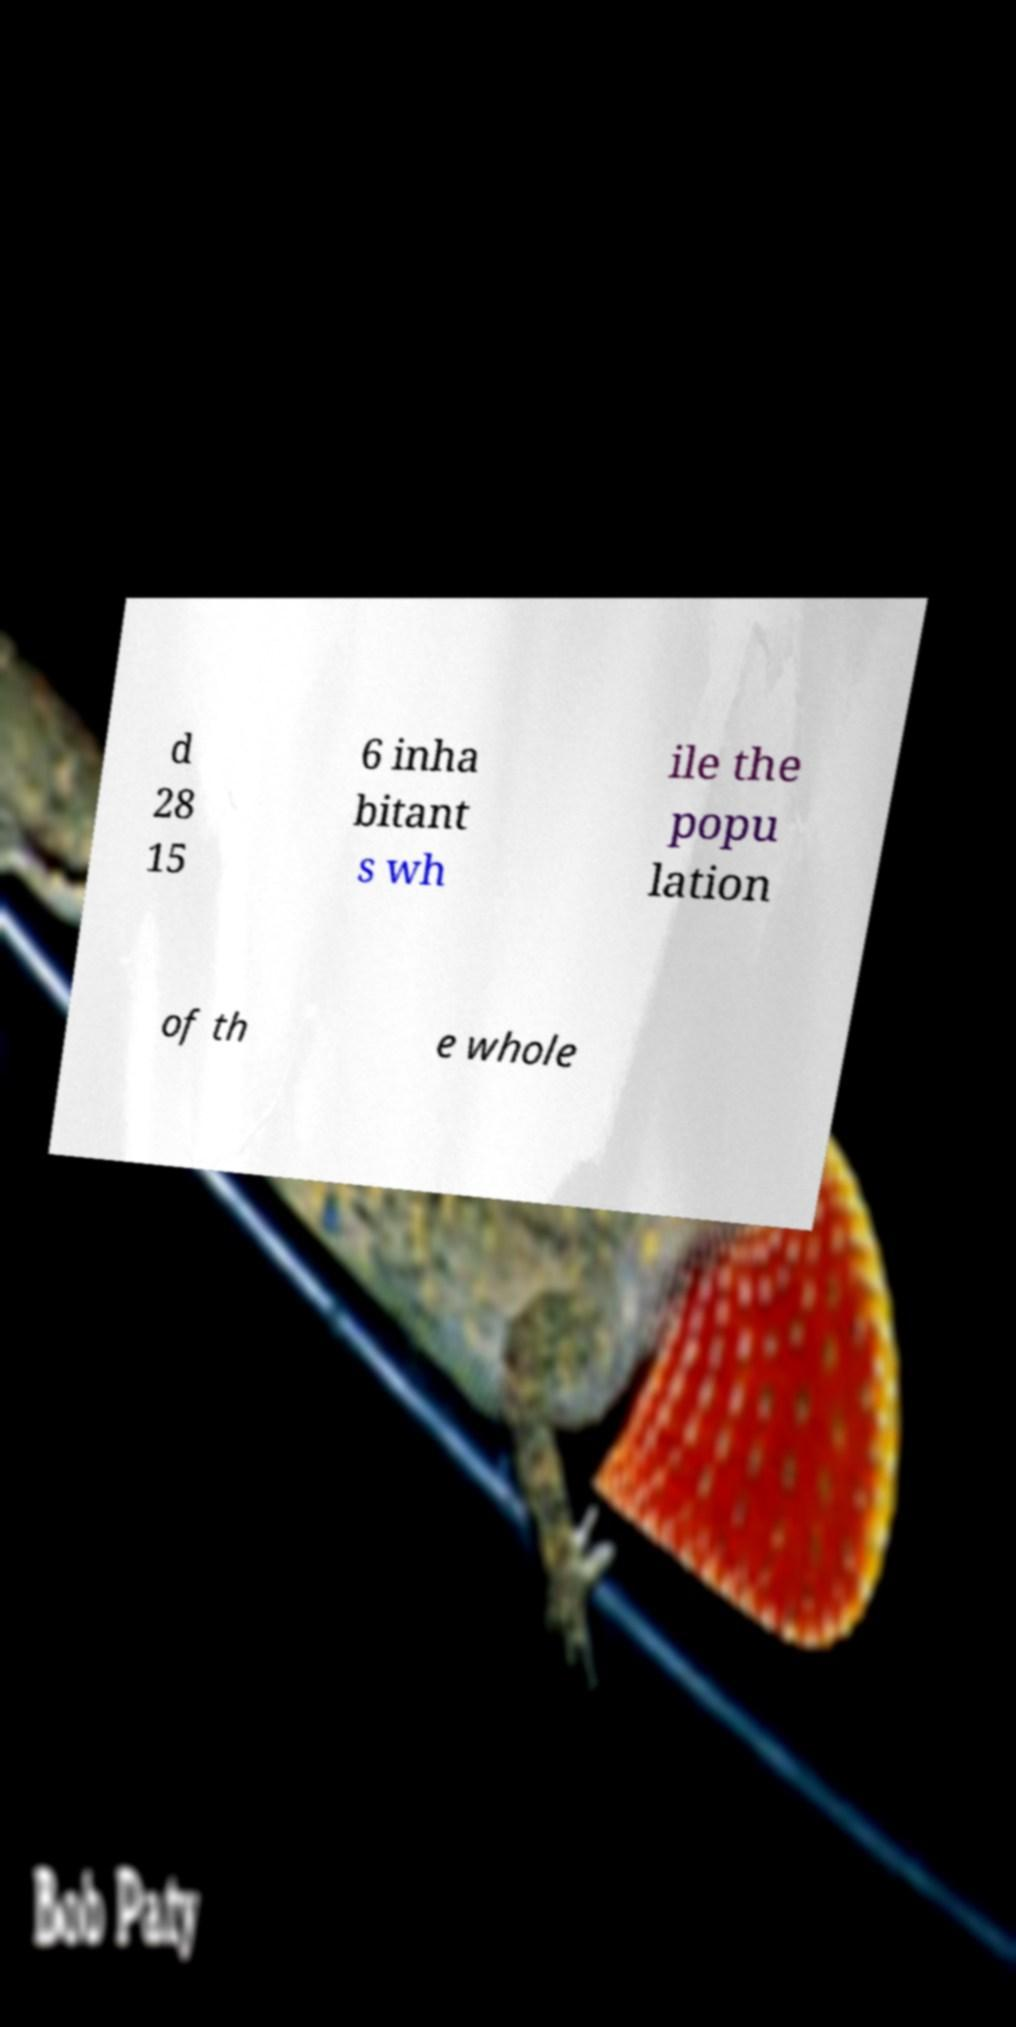Can you accurately transcribe the text from the provided image for me? d 28 15 6 inha bitant s wh ile the popu lation of th e whole 